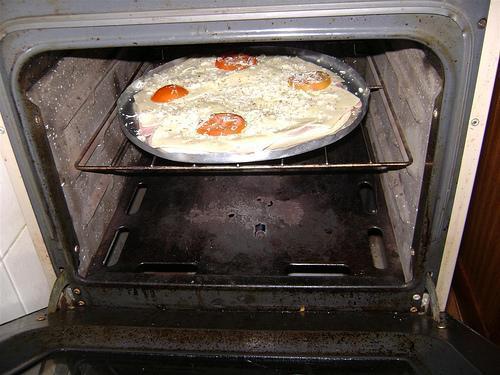How many tomato slices?
Give a very brief answer. 4. How many racks are in the oven?
Give a very brief answer. 1. 